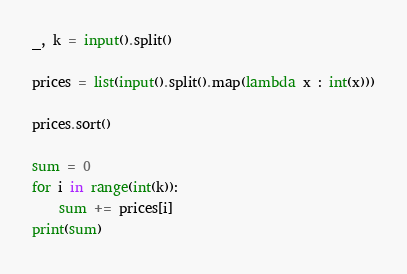Convert code to text. <code><loc_0><loc_0><loc_500><loc_500><_Python_>_, k = input().split()
 
prices = list(input().split().map(lambda x : int(x)))
 
prices.sort()
 
sum = 0
for i in range(int(k)):
	sum += prices[i]
print(sum)</code> 